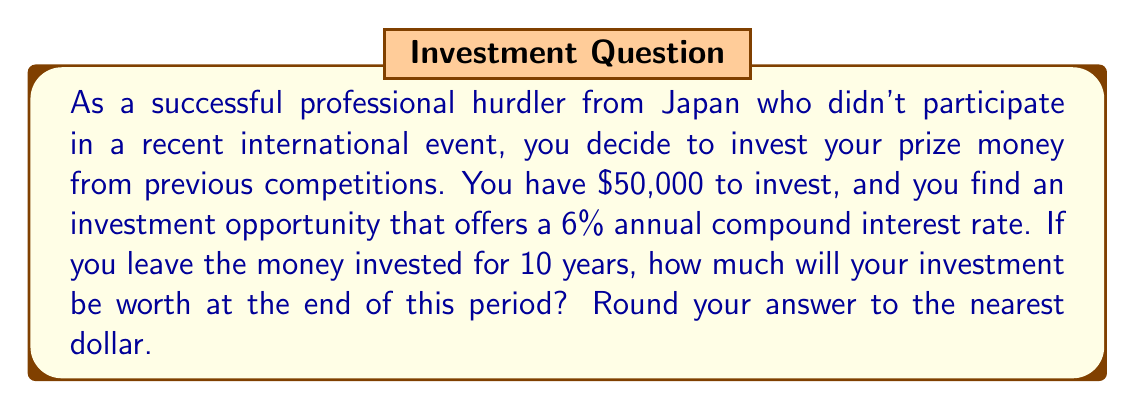Teach me how to tackle this problem. To solve this problem, we'll use the compound interest formula:

$$ A = P(1 + r)^n $$

Where:
$A$ = final amount
$P$ = principal (initial investment)
$r$ = annual interest rate (as a decimal)
$n$ = number of years

Given:
$P = \$50,000$
$r = 6\% = 0.06$
$n = 10$ years

Let's substitute these values into the formula:

$$ A = 50,000(1 + 0.06)^{10} $$

Now, let's calculate step by step:

1) First, calculate $(1 + 0.06)^{10}$:
   $$ (1.06)^{10} = 1.7908 $$
   (rounded to 4 decimal places for intermediate calculation)

2) Multiply this by the principal:
   $$ 50,000 \times 1.7908 = 89,540 $$

3) Round to the nearest dollar:
   $$ 89,540 \approx \$89,540 $$

Therefore, after 10 years, your investment will be worth $89,540.
Answer: $89,540 